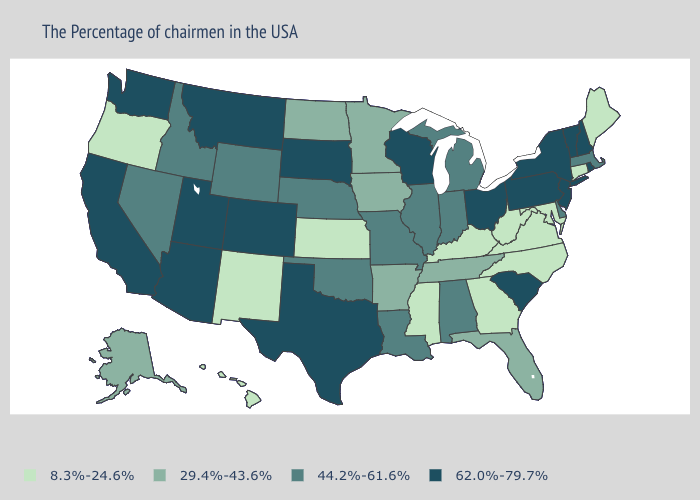What is the value of Illinois?
Short answer required. 44.2%-61.6%. Does Minnesota have a lower value than North Dakota?
Short answer required. No. What is the value of Tennessee?
Give a very brief answer. 29.4%-43.6%. What is the value of Wyoming?
Give a very brief answer. 44.2%-61.6%. Name the states that have a value in the range 62.0%-79.7%?
Keep it brief. Rhode Island, New Hampshire, Vermont, New York, New Jersey, Pennsylvania, South Carolina, Ohio, Wisconsin, Texas, South Dakota, Colorado, Utah, Montana, Arizona, California, Washington. Does South Carolina have the highest value in the USA?
Concise answer only. Yes. What is the value of Hawaii?
Concise answer only. 8.3%-24.6%. What is the lowest value in the USA?
Short answer required. 8.3%-24.6%. What is the value of New Mexico?
Give a very brief answer. 8.3%-24.6%. What is the lowest value in states that border North Carolina?
Short answer required. 8.3%-24.6%. Name the states that have a value in the range 8.3%-24.6%?
Write a very short answer. Maine, Connecticut, Maryland, Virginia, North Carolina, West Virginia, Georgia, Kentucky, Mississippi, Kansas, New Mexico, Oregon, Hawaii. Name the states that have a value in the range 29.4%-43.6%?
Answer briefly. Florida, Tennessee, Arkansas, Minnesota, Iowa, North Dakota, Alaska. What is the highest value in the Northeast ?
Answer briefly. 62.0%-79.7%. Does the first symbol in the legend represent the smallest category?
Keep it brief. Yes. Name the states that have a value in the range 29.4%-43.6%?
Give a very brief answer. Florida, Tennessee, Arkansas, Minnesota, Iowa, North Dakota, Alaska. 